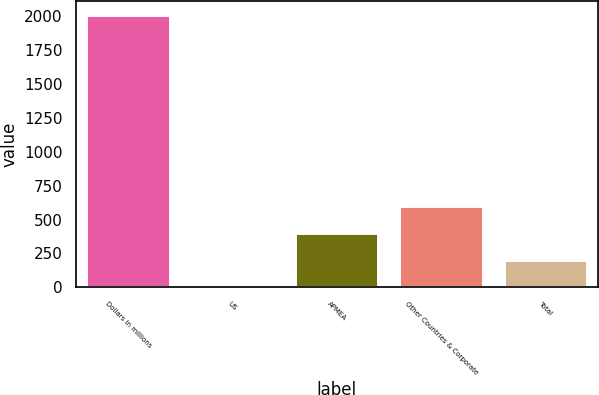Convert chart to OTSL. <chart><loc_0><loc_0><loc_500><loc_500><bar_chart><fcel>Dollars in millions<fcel>US<fcel>APMEA<fcel>Other Countries & Corporate<fcel>Total<nl><fcel>2009<fcel>1<fcel>402.6<fcel>603.4<fcel>201.8<nl></chart> 